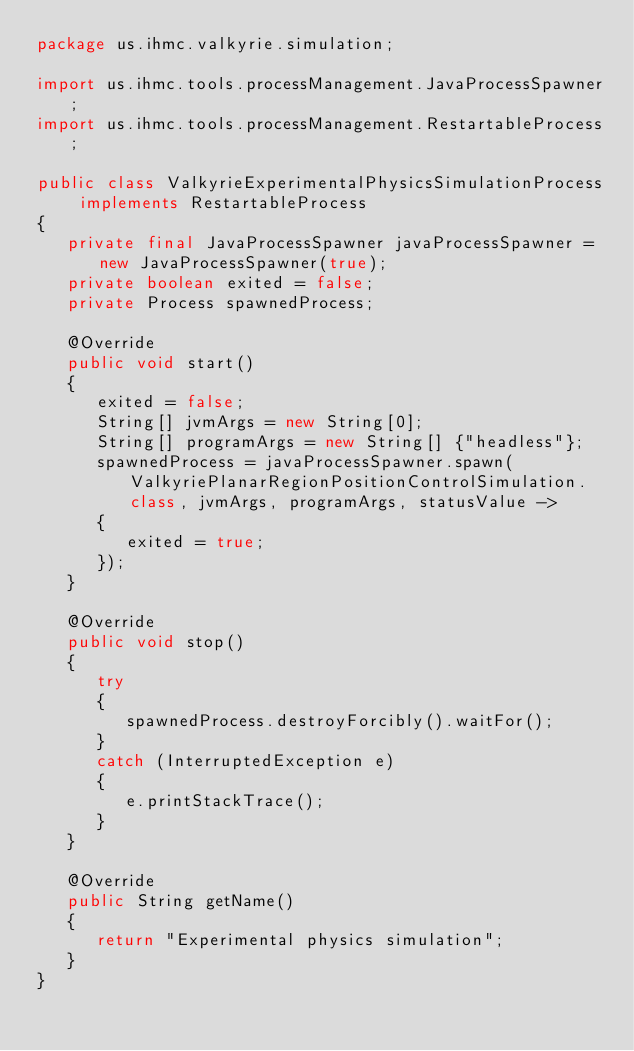Convert code to text. <code><loc_0><loc_0><loc_500><loc_500><_Java_>package us.ihmc.valkyrie.simulation;

import us.ihmc.tools.processManagement.JavaProcessSpawner;
import us.ihmc.tools.processManagement.RestartableProcess;

public class ValkyrieExperimentalPhysicsSimulationProcess implements RestartableProcess
{
   private final JavaProcessSpawner javaProcessSpawner = new JavaProcessSpawner(true);
   private boolean exited = false;
   private Process spawnedProcess;

   @Override
   public void start()
   {
      exited = false;
      String[] jvmArgs = new String[0];
      String[] programArgs = new String[] {"headless"};
      spawnedProcess = javaProcessSpawner.spawn(ValkyriePlanarRegionPositionControlSimulation.class, jvmArgs, programArgs, statusValue ->
      {
         exited = true;
      });
   }

   @Override
   public void stop()
   {
      try
      {
         spawnedProcess.destroyForcibly().waitFor();
      }
      catch (InterruptedException e)
      {
         e.printStackTrace();
      }
   }

   @Override
   public String getName()
   {
      return "Experimental physics simulation";
   }
}
</code> 